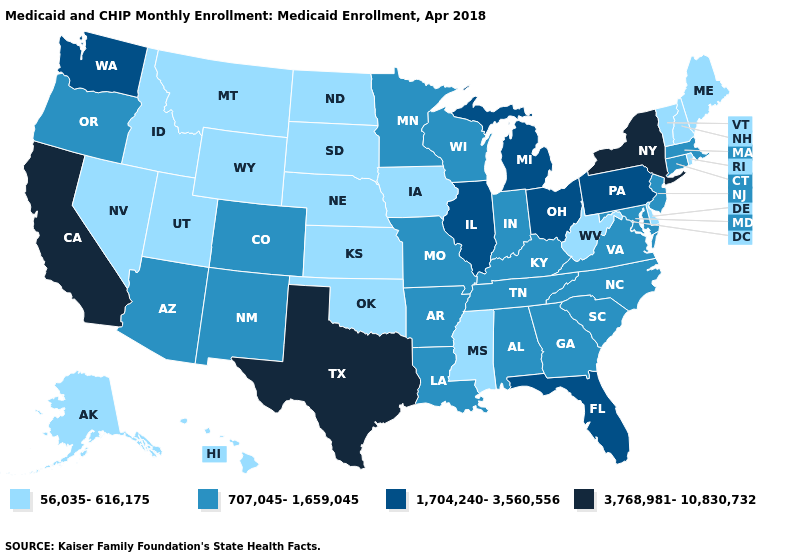Name the states that have a value in the range 3,768,981-10,830,732?
Answer briefly. California, New York, Texas. Among the states that border Vermont , which have the highest value?
Give a very brief answer. New York. Name the states that have a value in the range 56,035-616,175?
Answer briefly. Alaska, Delaware, Hawaii, Idaho, Iowa, Kansas, Maine, Mississippi, Montana, Nebraska, Nevada, New Hampshire, North Dakota, Oklahoma, Rhode Island, South Dakota, Utah, Vermont, West Virginia, Wyoming. Does Kansas have the highest value in the MidWest?
Short answer required. No. What is the value of North Dakota?
Write a very short answer. 56,035-616,175. What is the value of New Mexico?
Short answer required. 707,045-1,659,045. Name the states that have a value in the range 3,768,981-10,830,732?
Short answer required. California, New York, Texas. Does the map have missing data?
Keep it brief. No. What is the highest value in the USA?
Quick response, please. 3,768,981-10,830,732. What is the value of Oklahoma?
Keep it brief. 56,035-616,175. What is the lowest value in the MidWest?
Quick response, please. 56,035-616,175. Name the states that have a value in the range 707,045-1,659,045?
Be succinct. Alabama, Arizona, Arkansas, Colorado, Connecticut, Georgia, Indiana, Kentucky, Louisiana, Maryland, Massachusetts, Minnesota, Missouri, New Jersey, New Mexico, North Carolina, Oregon, South Carolina, Tennessee, Virginia, Wisconsin. What is the highest value in the USA?
Short answer required. 3,768,981-10,830,732. Which states have the highest value in the USA?
Quick response, please. California, New York, Texas. 